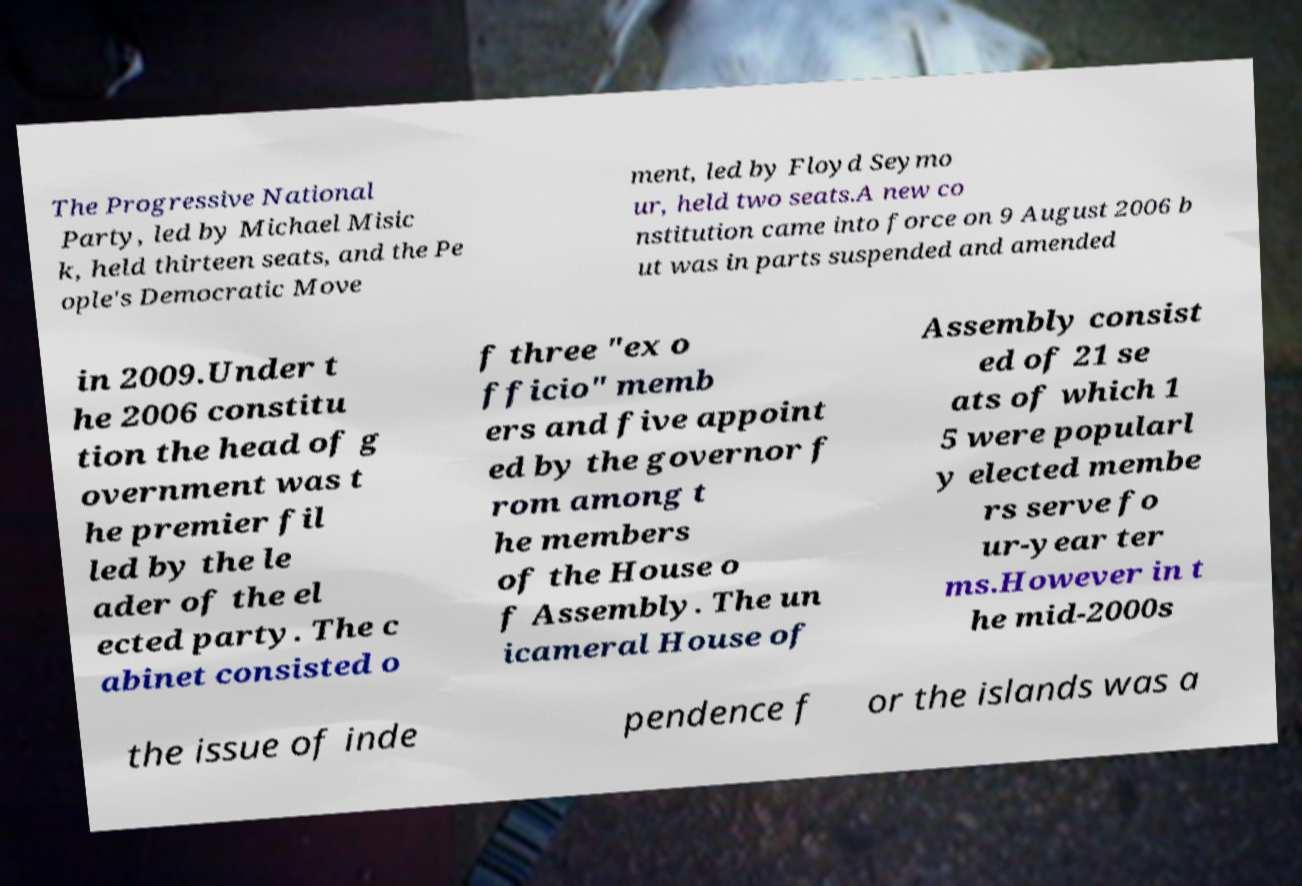Can you read and provide the text displayed in the image?This photo seems to have some interesting text. Can you extract and type it out for me? The Progressive National Party, led by Michael Misic k, held thirteen seats, and the Pe ople's Democratic Move ment, led by Floyd Seymo ur, held two seats.A new co nstitution came into force on 9 August 2006 b ut was in parts suspended and amended in 2009.Under t he 2006 constitu tion the head of g overnment was t he premier fil led by the le ader of the el ected party. The c abinet consisted o f three "ex o fficio" memb ers and five appoint ed by the governor f rom among t he members of the House o f Assembly. The un icameral House of Assembly consist ed of 21 se ats of which 1 5 were popularl y elected membe rs serve fo ur-year ter ms.However in t he mid-2000s the issue of inde pendence f or the islands was a 